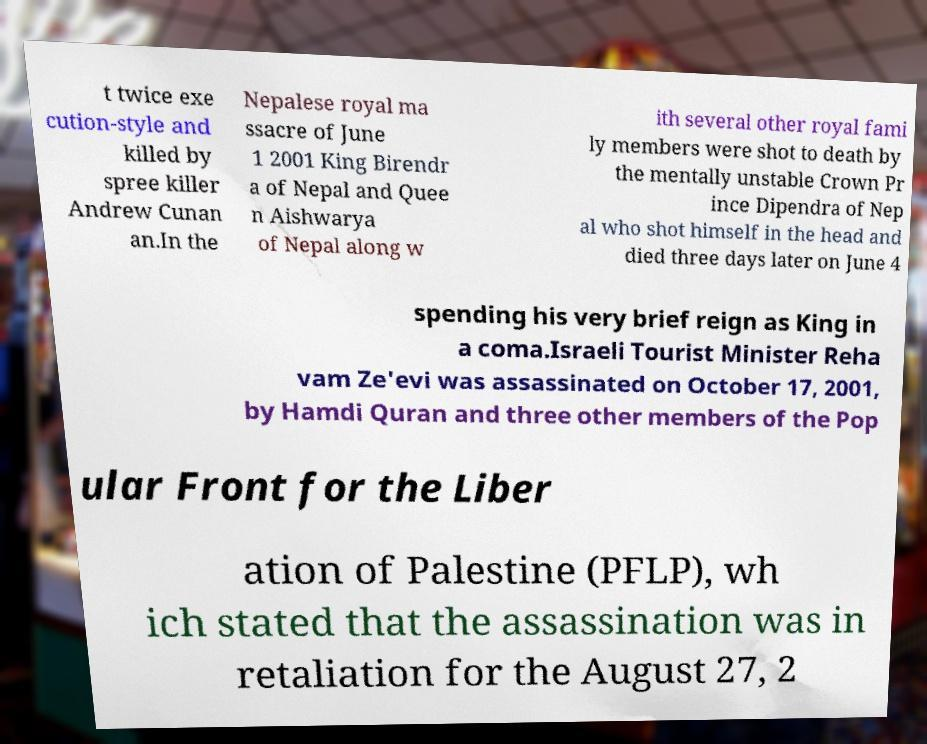For documentation purposes, I need the text within this image transcribed. Could you provide that? t twice exe cution-style and killed by spree killer Andrew Cunan an.In the Nepalese royal ma ssacre of June 1 2001 King Birendr a of Nepal and Quee n Aishwarya of Nepal along w ith several other royal fami ly members were shot to death by the mentally unstable Crown Pr ince Dipendra of Nep al who shot himself in the head and died three days later on June 4 spending his very brief reign as King in a coma.Israeli Tourist Minister Reha vam Ze'evi was assassinated on October 17, 2001, by Hamdi Quran and three other members of the Pop ular Front for the Liber ation of Palestine (PFLP), wh ich stated that the assassination was in retaliation for the August 27, 2 